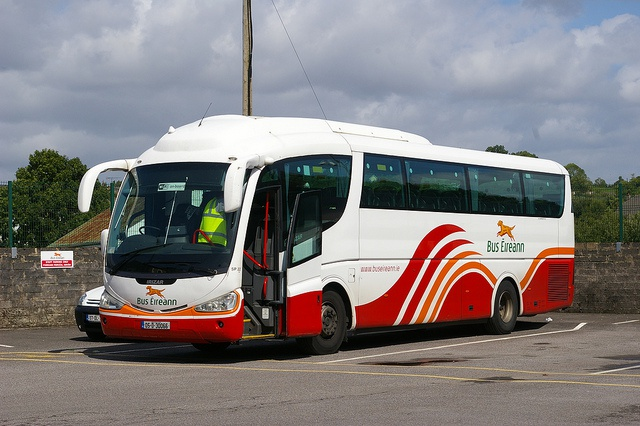Describe the objects in this image and their specific colors. I can see bus in darkgray, black, lightgray, brown, and gray tones, people in darkgray, black, yellow, green, and teal tones, and car in darkgray, black, white, and gray tones in this image. 